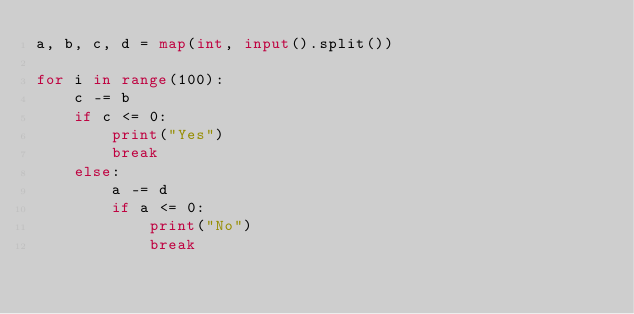Convert code to text. <code><loc_0><loc_0><loc_500><loc_500><_Python_>a, b, c, d = map(int, input().split())

for i in range(100):
    c -= b
    if c <= 0:
        print("Yes")
        break
    else:
        a -= d
        if a <= 0:
            print("No")
            break</code> 